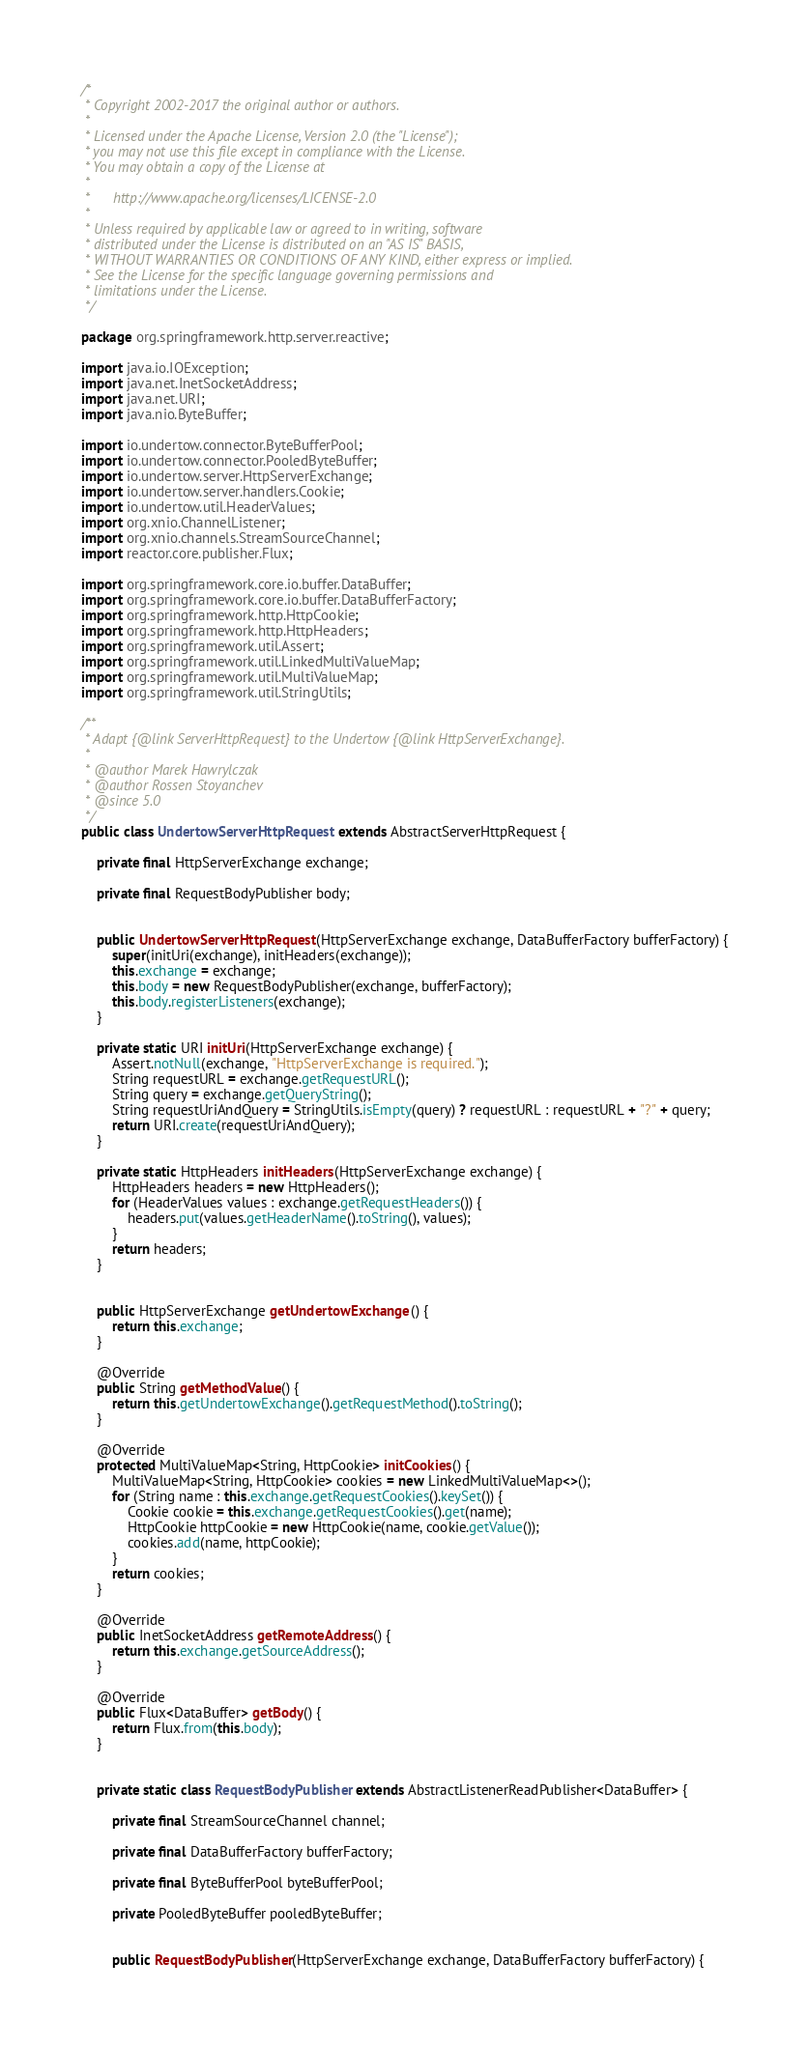<code> <loc_0><loc_0><loc_500><loc_500><_Java_>/*
 * Copyright 2002-2017 the original author or authors.
 *
 * Licensed under the Apache License, Version 2.0 (the "License");
 * you may not use this file except in compliance with the License.
 * You may obtain a copy of the License at
 *
 *      http://www.apache.org/licenses/LICENSE-2.0
 *
 * Unless required by applicable law or agreed to in writing, software
 * distributed under the License is distributed on an "AS IS" BASIS,
 * WITHOUT WARRANTIES OR CONDITIONS OF ANY KIND, either express or implied.
 * See the License for the specific language governing permissions and
 * limitations under the License.
 */

package org.springframework.http.server.reactive;

import java.io.IOException;
import java.net.InetSocketAddress;
import java.net.URI;
import java.nio.ByteBuffer;

import io.undertow.connector.ByteBufferPool;
import io.undertow.connector.PooledByteBuffer;
import io.undertow.server.HttpServerExchange;
import io.undertow.server.handlers.Cookie;
import io.undertow.util.HeaderValues;
import org.xnio.ChannelListener;
import org.xnio.channels.StreamSourceChannel;
import reactor.core.publisher.Flux;

import org.springframework.core.io.buffer.DataBuffer;
import org.springframework.core.io.buffer.DataBufferFactory;
import org.springframework.http.HttpCookie;
import org.springframework.http.HttpHeaders;
import org.springframework.util.Assert;
import org.springframework.util.LinkedMultiValueMap;
import org.springframework.util.MultiValueMap;
import org.springframework.util.StringUtils;

/**
 * Adapt {@link ServerHttpRequest} to the Undertow {@link HttpServerExchange}.
 *
 * @author Marek Hawrylczak
 * @author Rossen Stoyanchev
 * @since 5.0
 */
public class UndertowServerHttpRequest extends AbstractServerHttpRequest {

	private final HttpServerExchange exchange;

	private final RequestBodyPublisher body;


	public UndertowServerHttpRequest(HttpServerExchange exchange, DataBufferFactory bufferFactory) {
		super(initUri(exchange), initHeaders(exchange));
		this.exchange = exchange;
		this.body = new RequestBodyPublisher(exchange, bufferFactory);
		this.body.registerListeners(exchange);
	}

	private static URI initUri(HttpServerExchange exchange) {
		Assert.notNull(exchange, "HttpServerExchange is required.");
		String requestURL = exchange.getRequestURL();
		String query = exchange.getQueryString();
		String requestUriAndQuery = StringUtils.isEmpty(query) ? requestURL : requestURL + "?" + query;
		return URI.create(requestUriAndQuery);
	}

	private static HttpHeaders initHeaders(HttpServerExchange exchange) {
		HttpHeaders headers = new HttpHeaders();
		for (HeaderValues values : exchange.getRequestHeaders()) {
			headers.put(values.getHeaderName().toString(), values);
		}
		return headers;
	}


	public HttpServerExchange getUndertowExchange() {
		return this.exchange;
	}

	@Override
	public String getMethodValue() {
		return this.getUndertowExchange().getRequestMethod().toString();
	}

	@Override
	protected MultiValueMap<String, HttpCookie> initCookies() {
		MultiValueMap<String, HttpCookie> cookies = new LinkedMultiValueMap<>();
		for (String name : this.exchange.getRequestCookies().keySet()) {
			Cookie cookie = this.exchange.getRequestCookies().get(name);
			HttpCookie httpCookie = new HttpCookie(name, cookie.getValue());
			cookies.add(name, httpCookie);
		}
		return cookies;
	}

	@Override
	public InetSocketAddress getRemoteAddress() {
		return this.exchange.getSourceAddress();
	}

	@Override
	public Flux<DataBuffer> getBody() {
		return Flux.from(this.body);
	}


	private static class RequestBodyPublisher extends AbstractListenerReadPublisher<DataBuffer> {

		private final StreamSourceChannel channel;

		private final DataBufferFactory bufferFactory;

		private final ByteBufferPool byteBufferPool;

		private PooledByteBuffer pooledByteBuffer;


		public RequestBodyPublisher(HttpServerExchange exchange, DataBufferFactory bufferFactory) {</code> 